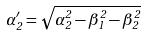Convert formula to latex. <formula><loc_0><loc_0><loc_500><loc_500>\alpha ^ { \prime } _ { 2 } = \sqrt { \alpha _ { 2 } ^ { 2 } - \beta _ { 1 } ^ { 2 } - \beta _ { 2 } ^ { 2 } }</formula> 